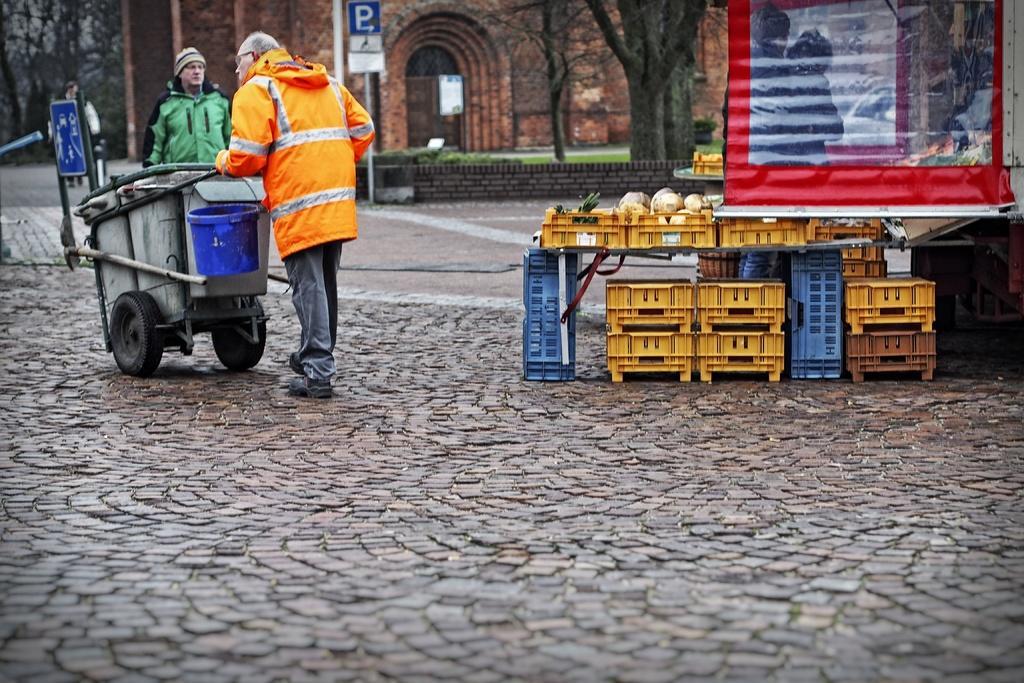Describe this image in one or two sentences. In this picture we can see a banner, basket with vegetables in it, trolley, bucket, signboards, two people on the ground, trees and in the background we can see a building. 